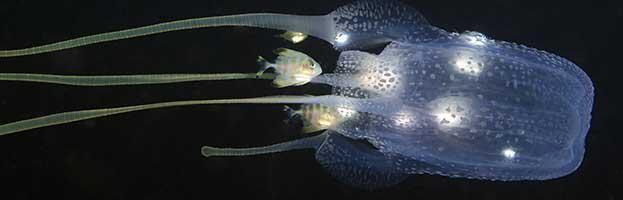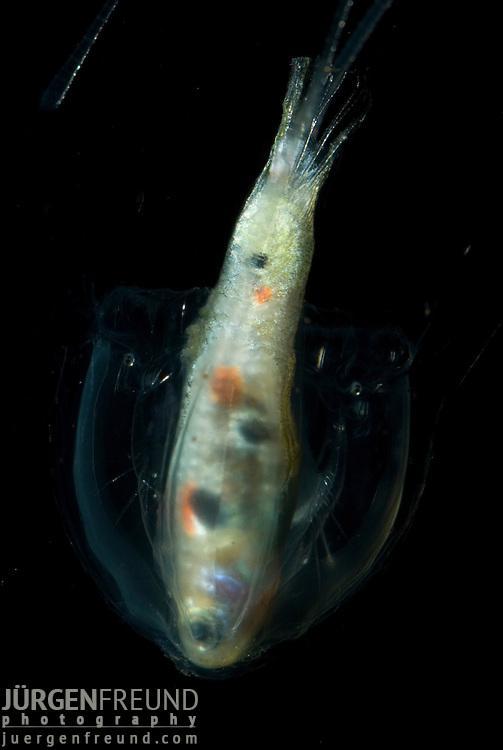The first image is the image on the left, the second image is the image on the right. Given the left and right images, does the statement "Both jellyfish are upside down." hold true? Answer yes or no. No. The first image is the image on the left, the second image is the image on the right. Assess this claim about the two images: "Two clear jellyfish are swimming downwards.". Correct or not? Answer yes or no. No. 